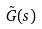<formula> <loc_0><loc_0><loc_500><loc_500>\tilde { G } ( s )</formula> 